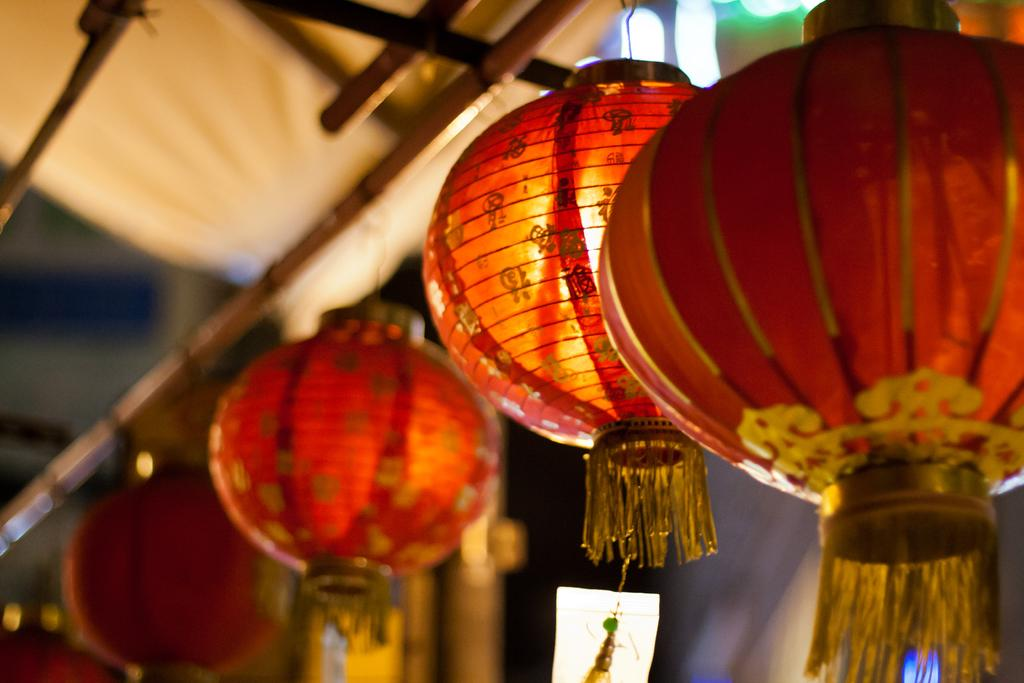What type of decorative objects are present in the image? There are paper lanterns in the image. How are the paper lanterns supported or held up? The paper lanterns are tied to a bamboo stick. What riddle can be solved using the calculator in the image? There is no calculator present in the image, so no riddle can be solved using it. 